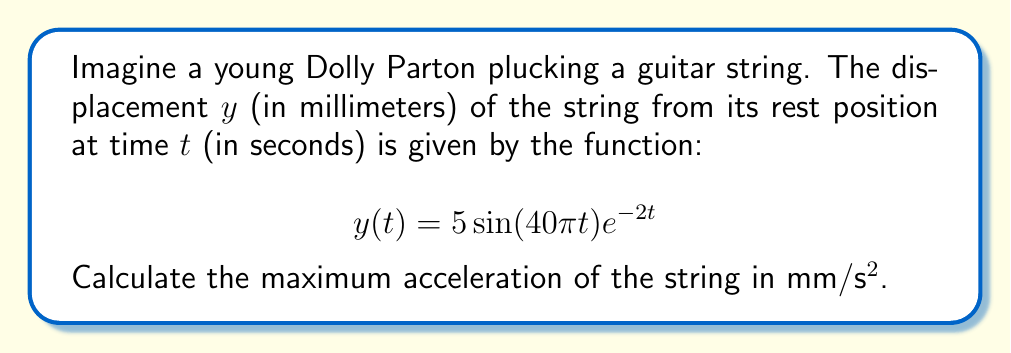Help me with this question. Let's approach this step-by-step:

1) To find acceleration, we need to take the second derivative of the displacement function.

2) First, let's find the velocity by taking the first derivative:

   $$\frac{dy}{dt} = 5(40\pi \cos(40\pi t))e^{-2t} + 5\sin(40\pi t)(-2e^{-2t})$$
   $$\frac{dy}{dt} = 5e^{-2t}(40\pi \cos(40\pi t) - 2\sin(40\pi t))$$

3) Now, let's take the second derivative to get acceleration:

   $$\frac{d^2y}{dt^2} = 5(-2e^{-2t})(40\pi \cos(40\pi t) - 2\sin(40\pi t)) + 5e^{-2t}(-40\pi \cdot 40\pi \sin(40\pi t) - 2 \cdot 40\pi \cos(40\pi t))$$

4) Simplify:

   $$\frac{d^2y}{dt^2} = 5e^{-2t}(-80\pi \cos(40\pi t) + 4\sin(40\pi t) - 1600\pi^2 \sin(40\pi t) - 80\pi \cos(40\pi t))$$
   $$\frac{d^2y}{dt^2} = 5e^{-2t}(-160\pi \cos(40\pi t) - (1600\pi^2 - 4)\sin(40\pi t))$$

5) The maximum acceleration will occur when this function reaches its maximum absolute value. This happens when both sine and cosine terms are at their maximum absolute values (1 or -1) and have the same sign.

6) Therefore, the maximum acceleration is:

   $$|a_{max}| = 5(160\pi + 1600\pi^2 - 4) \approx 78,961.69 \text{ mm/s²}$$
Answer: $78,961.69 \text{ mm/s²}$ 